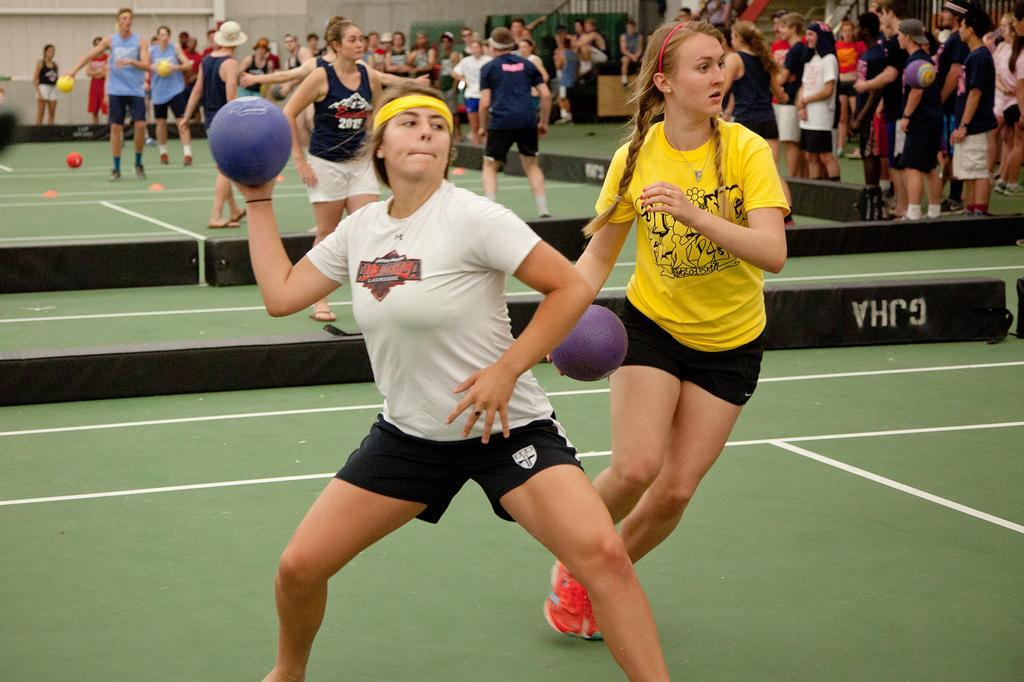How would you summarize this image in a sentence or two? There are groups of people standing. Among them few people are holding the balls. I can see the black color objects, which are placed on the floor. 